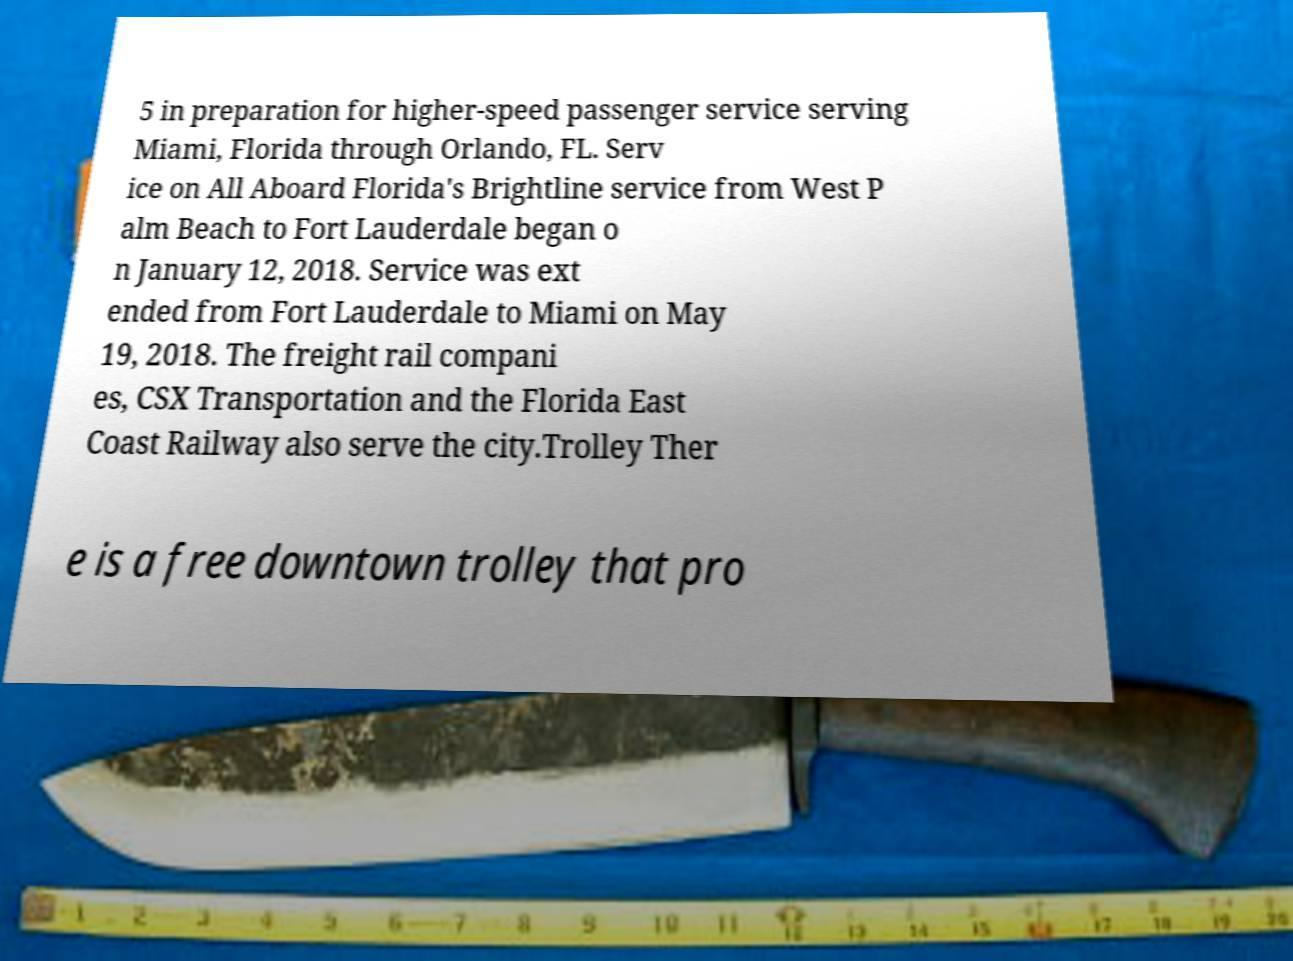Can you accurately transcribe the text from the provided image for me? 5 in preparation for higher-speed passenger service serving Miami, Florida through Orlando, FL. Serv ice on All Aboard Florida's Brightline service from West P alm Beach to Fort Lauderdale began o n January 12, 2018. Service was ext ended from Fort Lauderdale to Miami on May 19, 2018. The freight rail compani es, CSX Transportation and the Florida East Coast Railway also serve the city.Trolley Ther e is a free downtown trolley that pro 